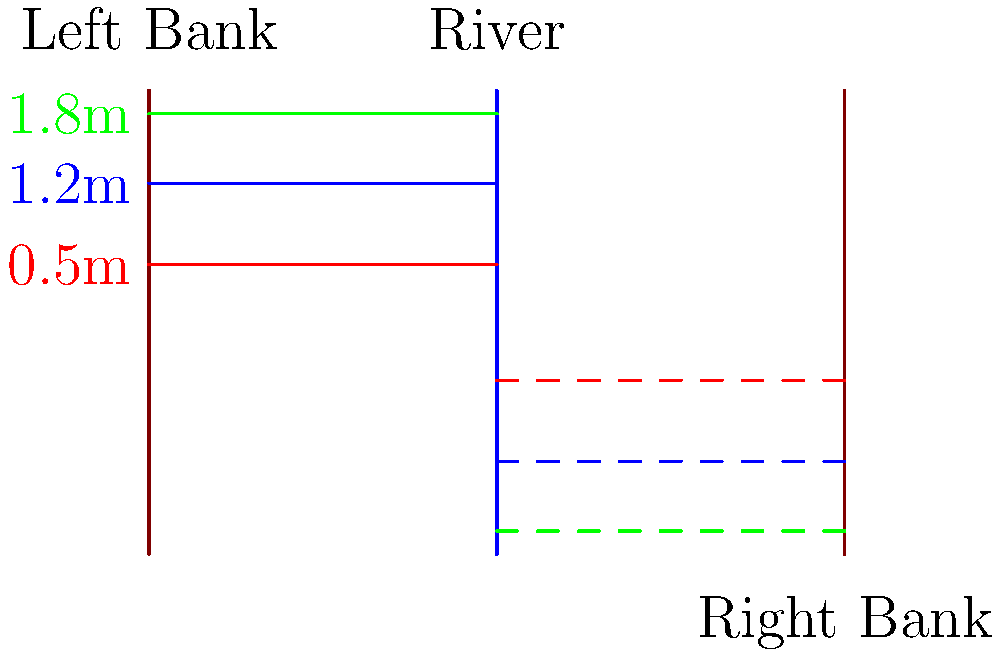The diagram shows flood water levels on the left bank of a river. If these levels are reflected across the river to estimate potential impact on the right bank, what would be the flood level on the right bank corresponding to the 1.8m level on the left bank? To solve this problem, we need to understand the concept of reflection in transformational geometry:

1. Reflection across a vertical line (in this case, the river) changes the sign of the x-coordinate while keeping the y-coordinate the same.

2. The flood levels on the left bank are positive values, measured upward from the base of the bank.

3. When reflected across the river, these levels will appear as negative values on the right bank, measured downward from the base of the right bank.

4. The magnitude of the flood level remains the same, only the direction changes.

5. Therefore, the 1.8m flood level on the left bank, when reflected across the river, will correspond to a -1.8m flood level on the right bank.

6. In terms of impact, this means the flood water would reach 1.8m below the base of the right bank.
Answer: -1.8m 